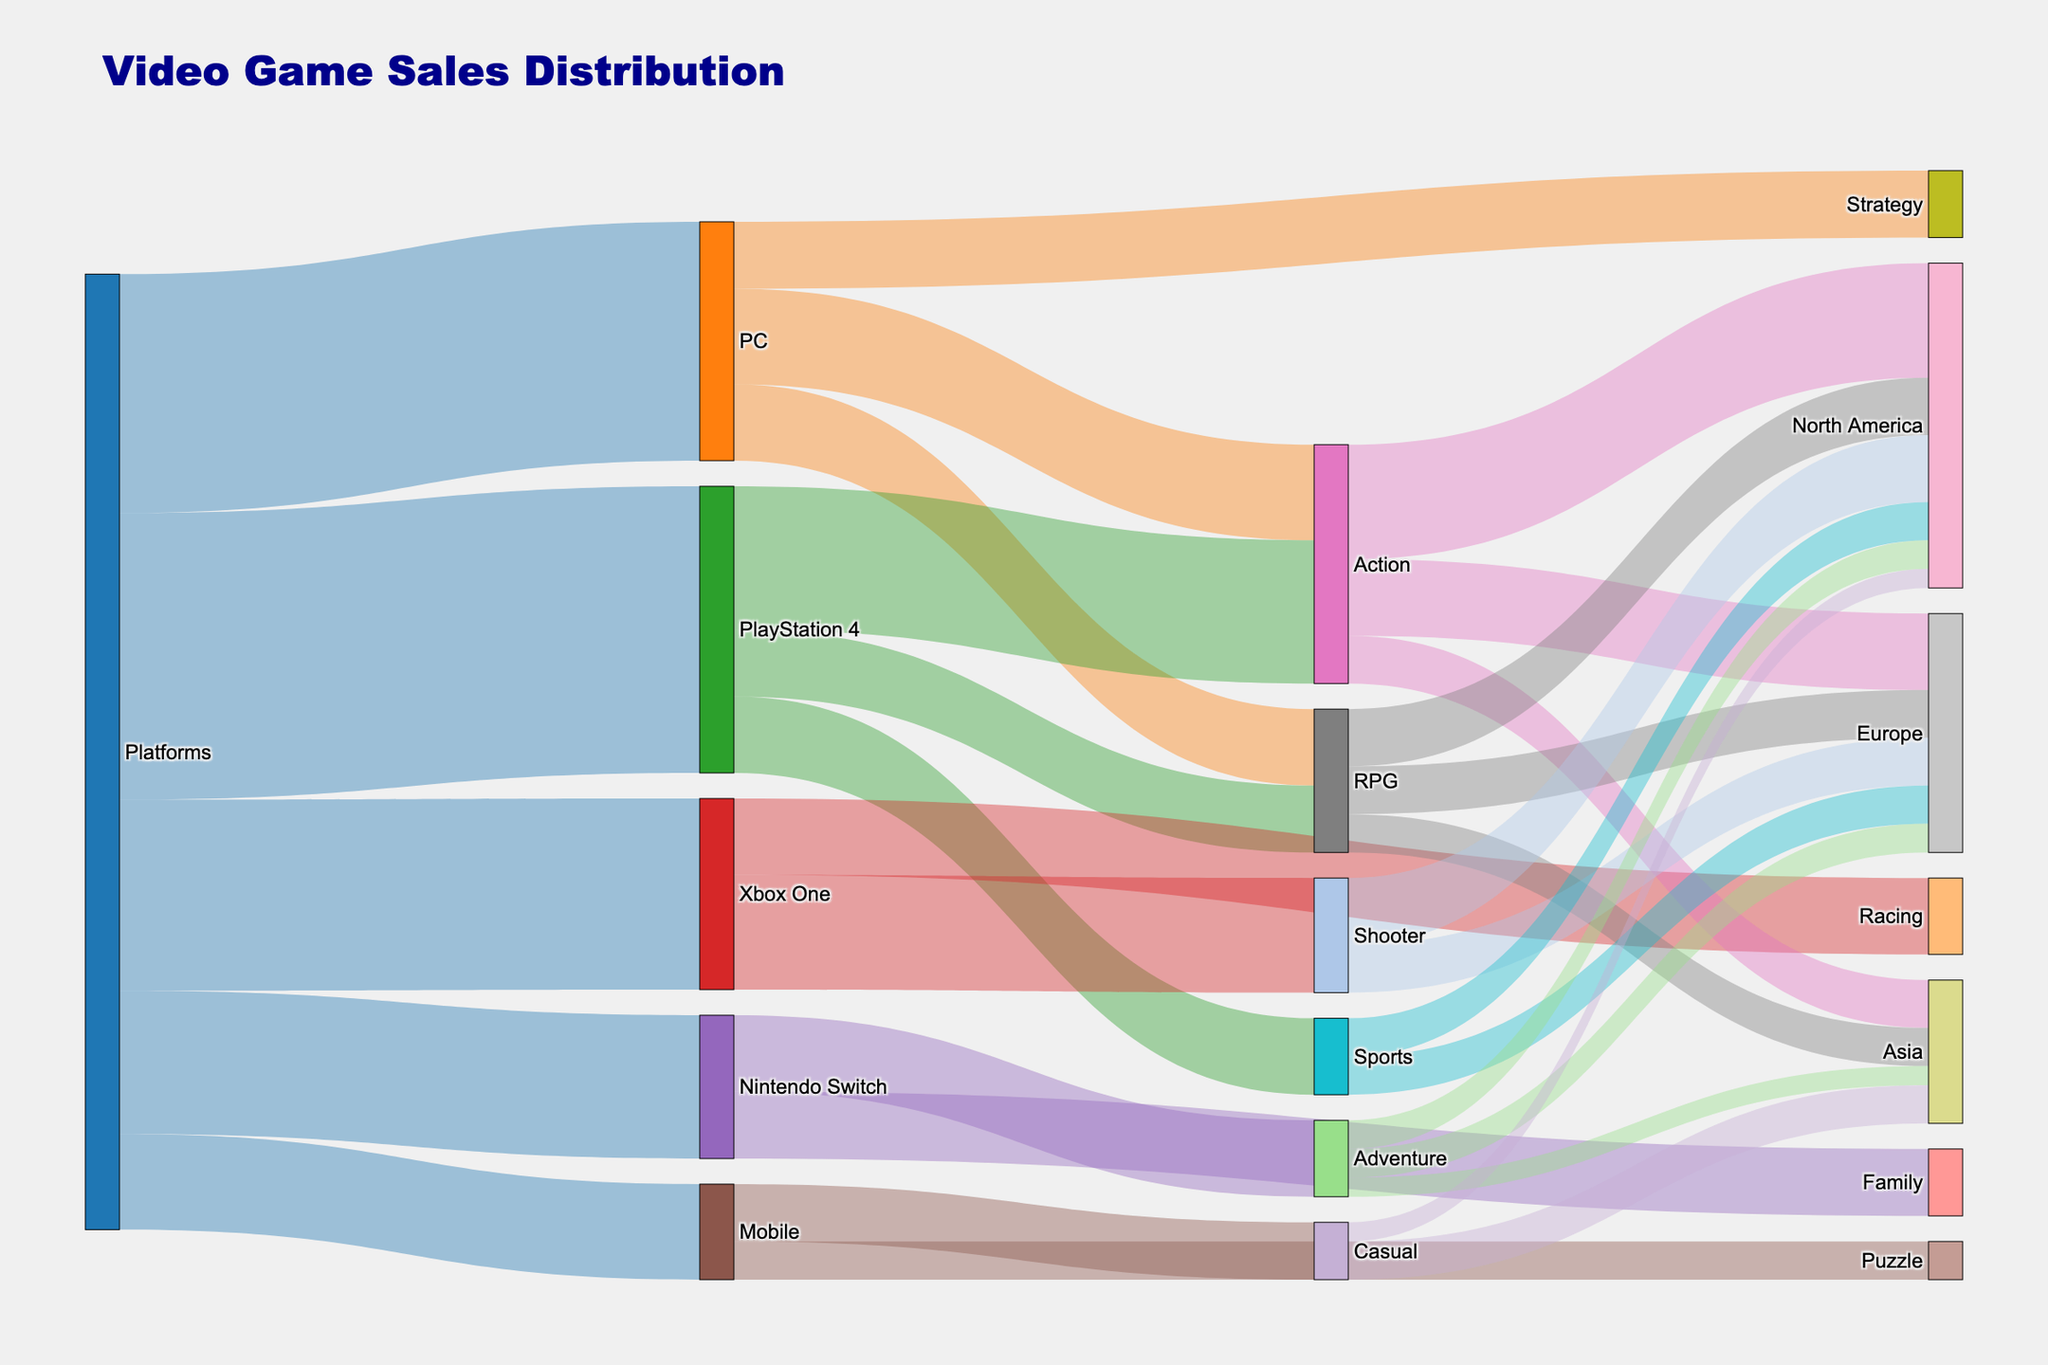What's the title of the figure? The title is displayed at the top of the figure.
Answer: Video Game Sales Distribution Which platform has the highest sales? By looking at the thickness and label of the links from the "Platforms" node, the "PlayStation 4" platform has the highest sales with a value of 30.
Answer: PlayStation 4 How many genres are there on the PC platform? The genres are linked from the "PC" node. Counting these, we find Action, RPG, and Strategy.
Answer: 3 Which region has the highest sales in the Action genre? Trace the "Action" node to its connected regions and compare their values. The highest value is for North America, which is 12.
Answer: North America What is the total sales value for the RPG genre? Sum the sales values for the RPG genre in all regions: North America (6) + Europe (5) + Asia (4) = 15.
Answer: 15 Compare the sales of Adventure games in Europe versus North America. Look at the values for Adventure in each region. Both Europe and North America have values of 3.
Answer: They are equal Which platform shows a sales value exclusively connected to the Sports genre? Check the genres connected to each platform. Only PlayStation 4 has a connection to Sports with a value of 8.
Answer: PlayStation 4 How does the sales value of Casual games in Asia compare to North America? Observe the values for Casual games in these regions. Asia has a value of 4, while North America has 2.
Answer: Asia has double the sales value Is there any genre exclusive to Mobile? If yes, which one? Identify the genres linked only to Mobile. Puzzle is exclusive to Mobile.
Answer: Puzzle What is the combined sales value of Strategy and Family genres? Sum the values of Strategy (7) and Family (7). 7 + 7 = 14.
Answer: 14 